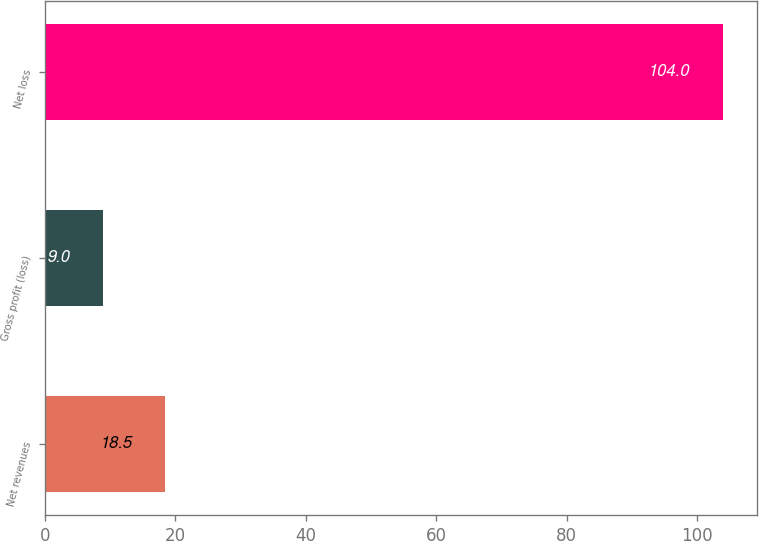Convert chart. <chart><loc_0><loc_0><loc_500><loc_500><bar_chart><fcel>Net revenues<fcel>Gross profit (loss)<fcel>Net loss<nl><fcel>18.5<fcel>9<fcel>104<nl></chart> 